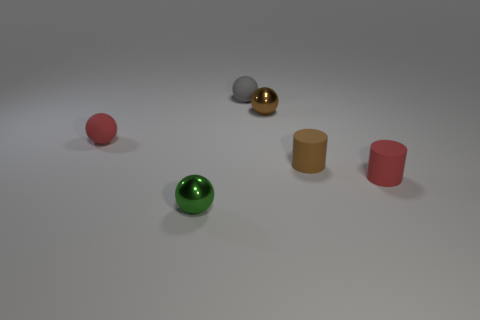How many brown objects are there?
Make the answer very short. 2. Are there more green metallic spheres than blue metallic cubes?
Make the answer very short. Yes. How many other things are there of the same size as the red matte ball?
Provide a short and direct response. 5. What material is the brown thing behind the red thing that is behind the red rubber object that is right of the tiny gray object?
Your response must be concise. Metal. Is the material of the green object the same as the brown ball behind the small red cylinder?
Make the answer very short. Yes. Is the number of rubber spheres behind the small gray ball less than the number of small rubber things on the left side of the small brown metallic object?
Keep it short and to the point. Yes. How many small red spheres are the same material as the small brown cylinder?
Provide a short and direct response. 1. There is a small metallic sphere on the right side of the shiny sphere that is in front of the brown ball; are there any tiny brown spheres in front of it?
Your answer should be compact. No. What number of spheres are either tiny green metal things or tiny objects?
Provide a succinct answer. 4. Does the small brown metallic thing have the same shape as the metallic thing that is in front of the brown metallic object?
Offer a very short reply. Yes. 